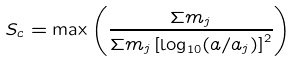Convert formula to latex. <formula><loc_0><loc_0><loc_500><loc_500>S _ { c } = \max \left ( \frac { \Sigma m _ { j } } { \Sigma m _ { j } \left [ \log _ { 1 0 } ( a / a _ { j } ) \right ] ^ { 2 } } \right )</formula> 